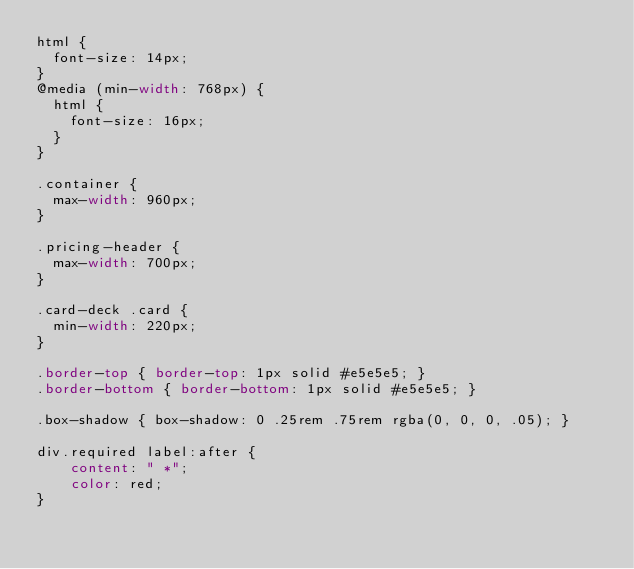Convert code to text. <code><loc_0><loc_0><loc_500><loc_500><_CSS_>html {
  font-size: 14px;
}
@media (min-width: 768px) {
  html {
    font-size: 16px;
  }
}

.container {
  max-width: 960px;
}

.pricing-header {
  max-width: 700px;
}

.card-deck .card {
  min-width: 220px;
}

.border-top { border-top: 1px solid #e5e5e5; }
.border-bottom { border-bottom: 1px solid #e5e5e5; }

.box-shadow { box-shadow: 0 .25rem .75rem rgba(0, 0, 0, .05); }

div.required label:after {
    content: " *";
    color: red;
}</code> 